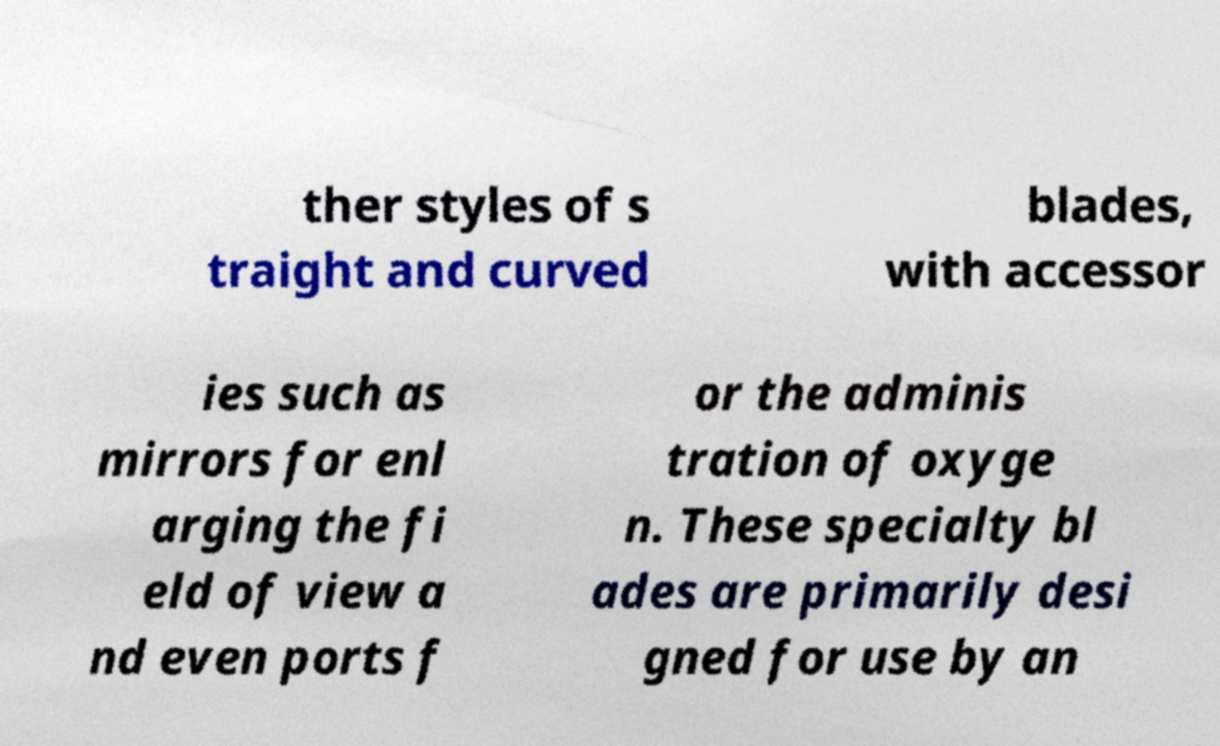Please identify and transcribe the text found in this image. ther styles of s traight and curved blades, with accessor ies such as mirrors for enl arging the fi eld of view a nd even ports f or the adminis tration of oxyge n. These specialty bl ades are primarily desi gned for use by an 